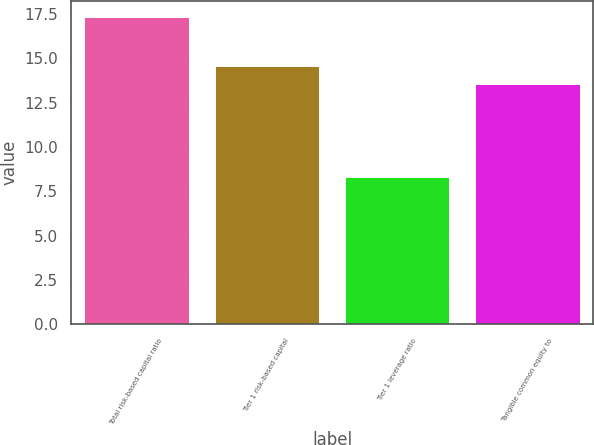<chart> <loc_0><loc_0><loc_500><loc_500><bar_chart><fcel>Total risk-based capital ratio<fcel>Tier 1 risk-based capital<fcel>Tier 1 leverage ratio<fcel>Tangible common equity to<nl><fcel>17.35<fcel>14.55<fcel>8.28<fcel>13.54<nl></chart> 